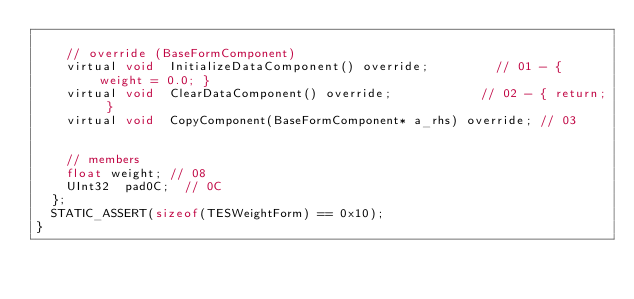<code> <loc_0><loc_0><loc_500><loc_500><_C_>
		// override (BaseFormComponent)
		virtual void	InitializeDataComponent() override;					// 01 - { weight = 0.0; }
		virtual void	ClearDataComponent() override;						// 02 - { return; }
		virtual void	CopyComponent(BaseFormComponent* a_rhs) override;	// 03


		// members
		float	weight;	// 08
		UInt32	pad0C;	// 0C
	};
	STATIC_ASSERT(sizeof(TESWeightForm) == 0x10);
}
</code> 